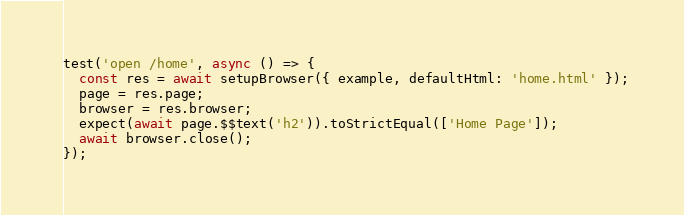<code> <loc_0><loc_0><loc_500><loc_500><_TypeScript_>test('open /home', async () => {
  const res = await setupBrowser({ example, defaultHtml: 'home.html' });
  page = res.page;
  browser = res.browser;
  expect(await page.$$text('h2')).toStrictEqual(['Home Page']);
  await browser.close();
});

</code> 